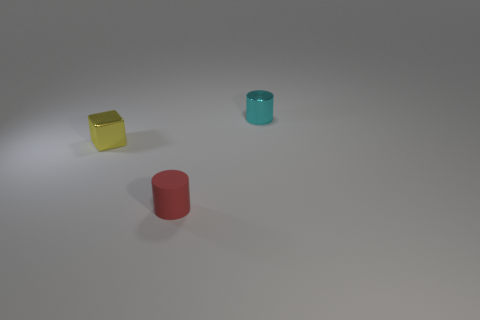There is a thing that is behind the small red cylinder and on the left side of the small shiny cylinder; what color is it? yellow 